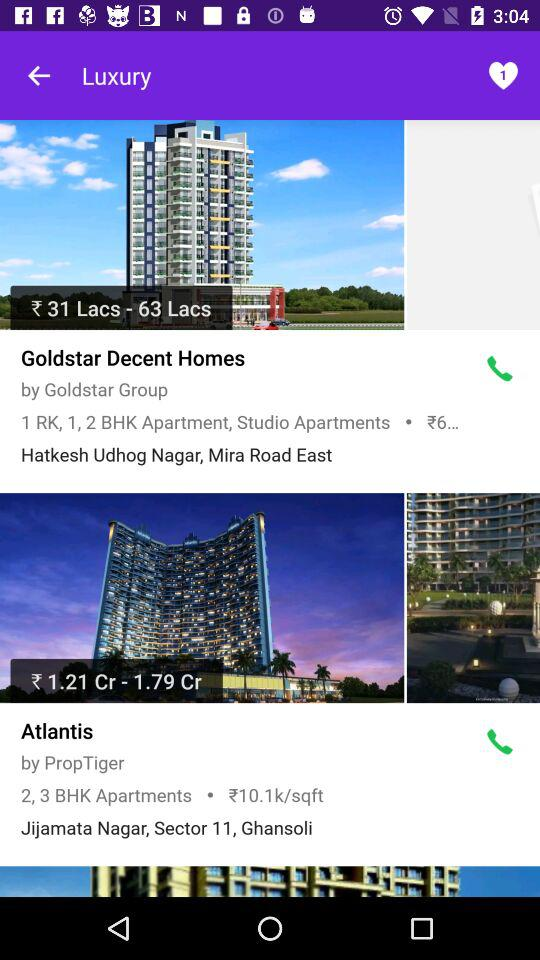What is the price range of the "Goldstar Decent Homes"? The price range is between ₹31 lacs and ₹63 lacs. 